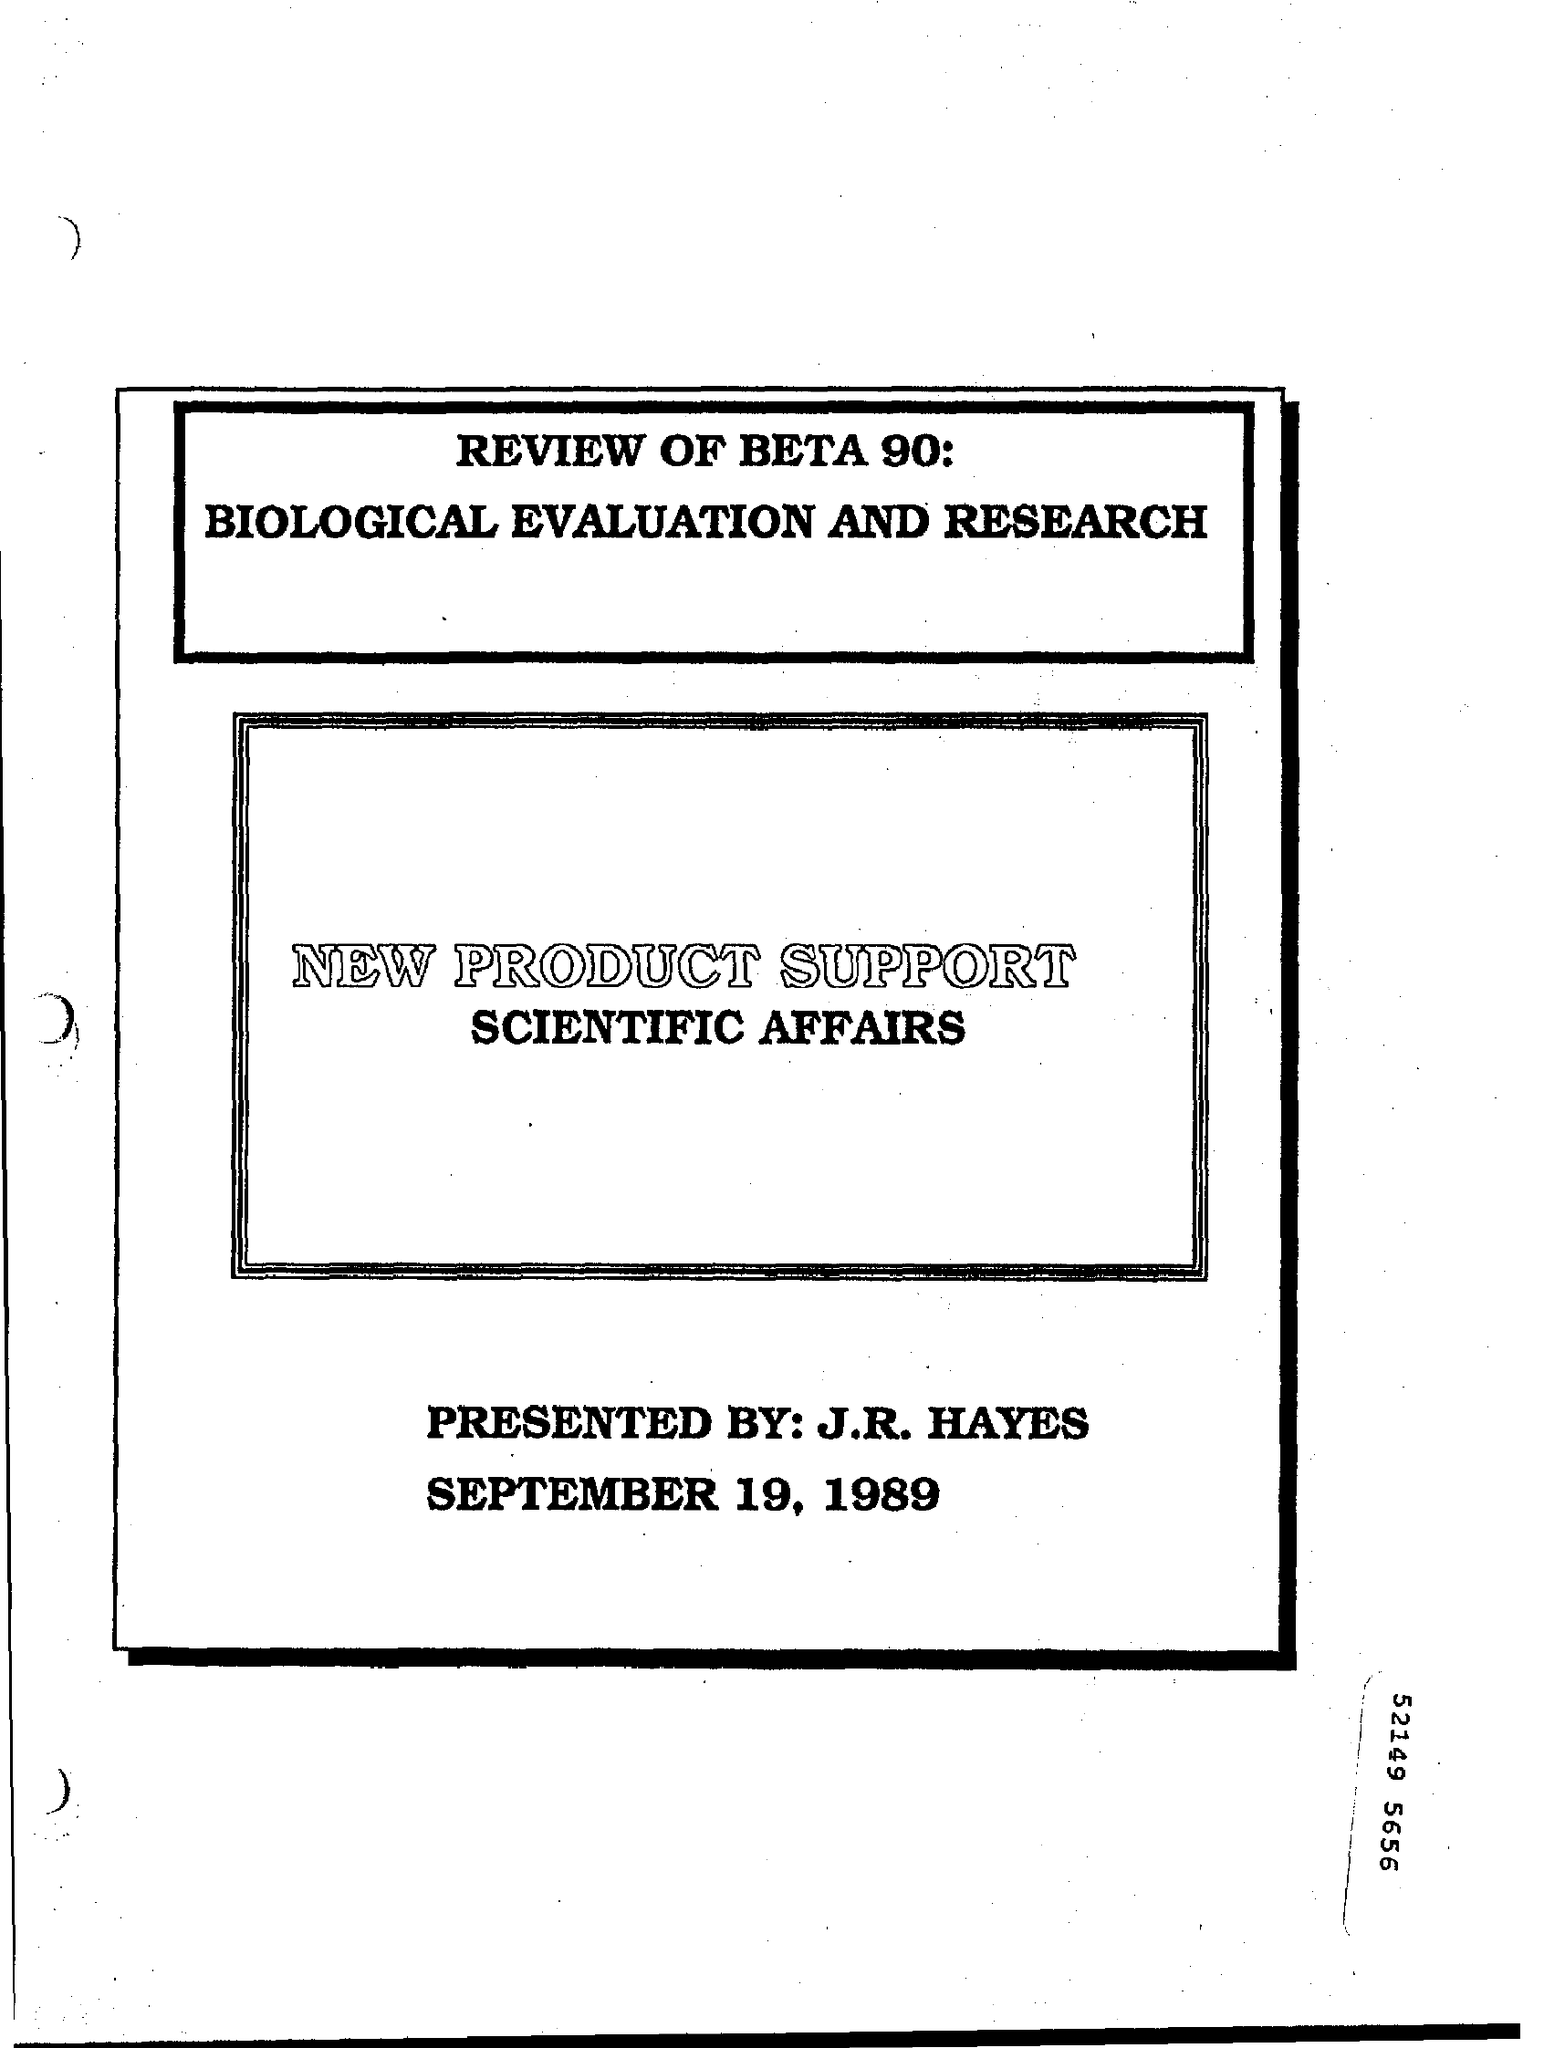Specify some key components in this picture. It is clear that John Hayes, who has presented this, is the individual in question. The main heading on the second rectangle of the page is "NEW PRODUCT SUPPORT. The second rectangle on the page contains the phrase 'Scientific Affairs'. The first rectangle at the top of the page contains a review of Beta 90: Biological Evaluation and Research. 